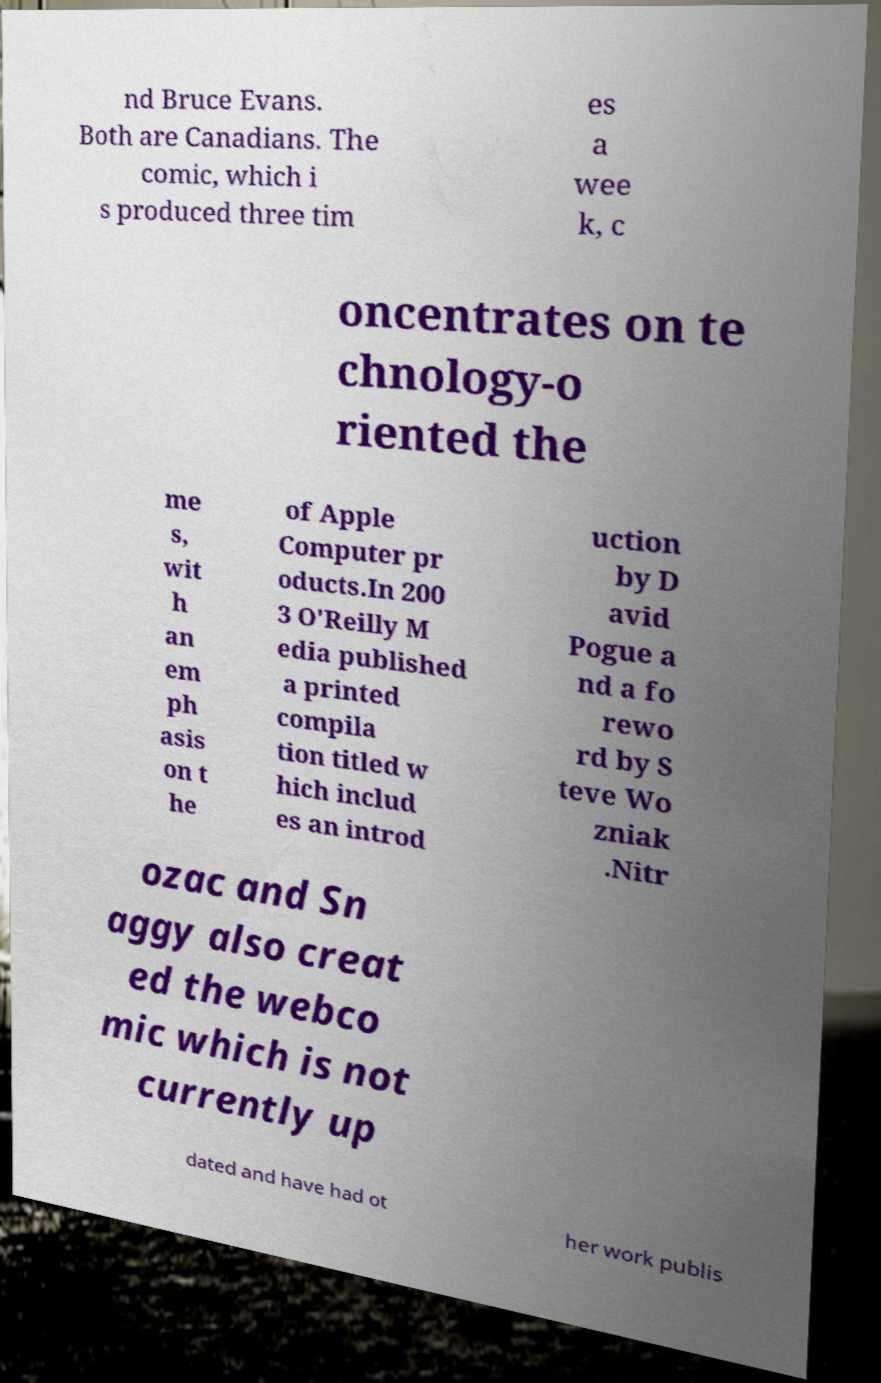Could you assist in decoding the text presented in this image and type it out clearly? nd Bruce Evans. Both are Canadians. The comic, which i s produced three tim es a wee k, c oncentrates on te chnology-o riented the me s, wit h an em ph asis on t he of Apple Computer pr oducts.In 200 3 O'Reilly M edia published a printed compila tion titled w hich includ es an introd uction by D avid Pogue a nd a fo rewo rd by S teve Wo zniak .Nitr ozac and Sn aggy also creat ed the webco mic which is not currently up dated and have had ot her work publis 